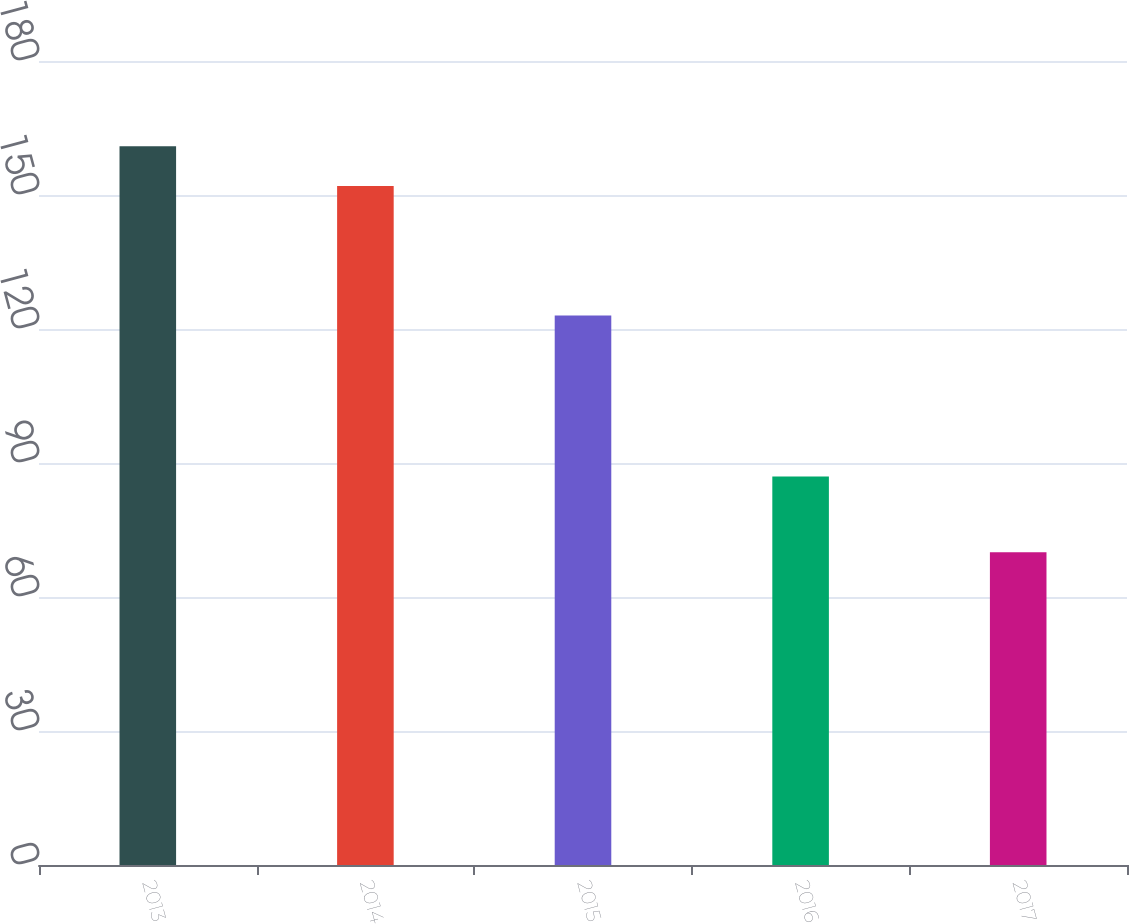Convert chart. <chart><loc_0><loc_0><loc_500><loc_500><bar_chart><fcel>2013<fcel>2014<fcel>2015<fcel>2016<fcel>2017<nl><fcel>160.9<fcel>152<fcel>123<fcel>87<fcel>70<nl></chart> 